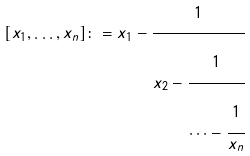Convert formula to latex. <formula><loc_0><loc_0><loc_500><loc_500>[ x _ { 1 } , \dots , x _ { n } ] \colon = x _ { 1 } - \cfrac { 1 } { x _ { 2 } - \cfrac { 1 } { \cdots - \cfrac { 1 } { x _ { n } } } }</formula> 